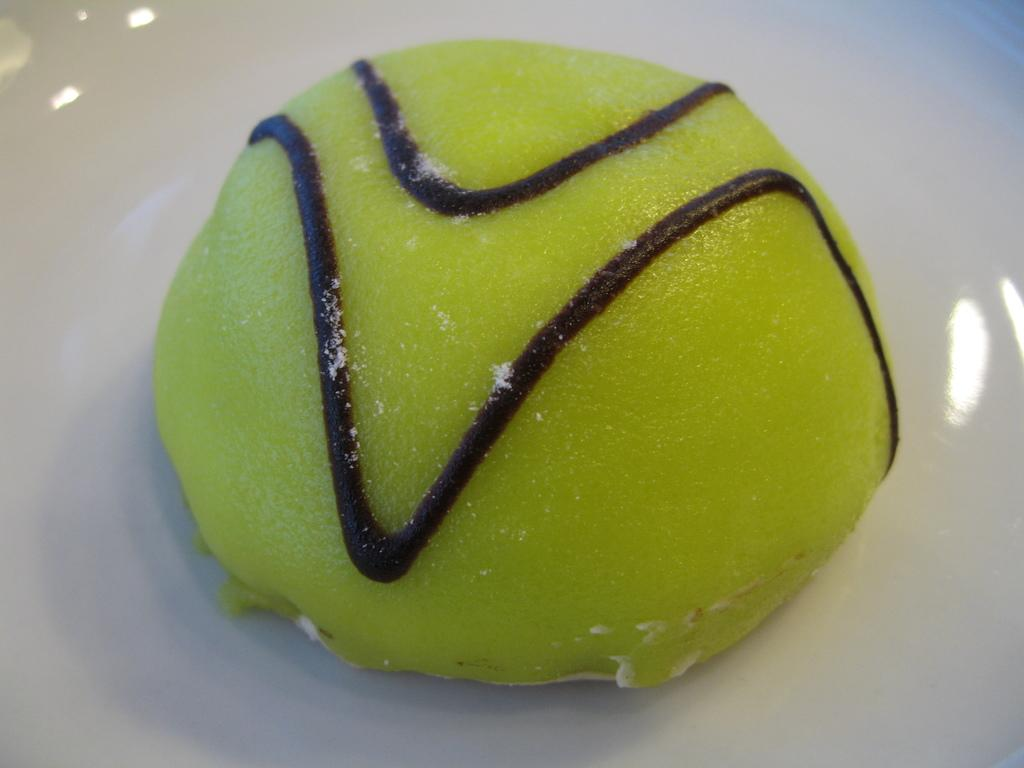What is the main subject of the image? The main subject of the image is food. Can you describe the surface on which the food is placed? The food is on a white platform. What type of hair is visible on the food in the image? There is no hair visible on the food in the image. How does the pain manifest itself in the image? There is no pain depicted in the image; it is a still image of food on a white platform. 